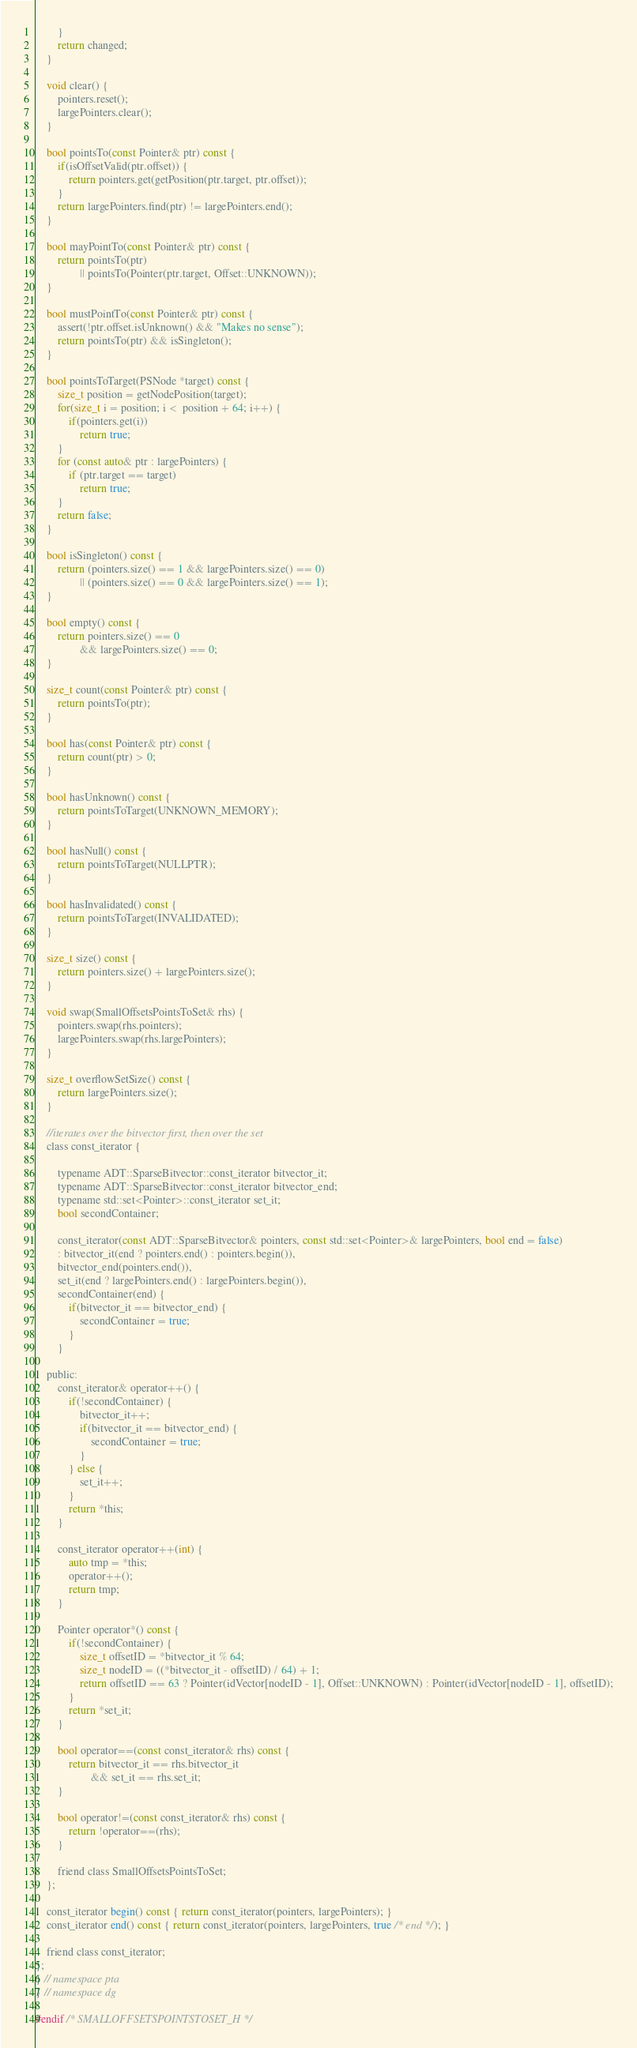Convert code to text. <code><loc_0><loc_0><loc_500><loc_500><_C_>        }
        return changed;
    }

    void clear() {
        pointers.reset();
        largePointers.clear();
    }

    bool pointsTo(const Pointer& ptr) const {
        if(isOffsetValid(ptr.offset)) {
            return pointers.get(getPosition(ptr.target, ptr.offset));
        }
        return largePointers.find(ptr) != largePointers.end();
    }

    bool mayPointTo(const Pointer& ptr) const {
        return pointsTo(ptr)
                || pointsTo(Pointer(ptr.target, Offset::UNKNOWN));
    }

    bool mustPointTo(const Pointer& ptr) const {
        assert(!ptr.offset.isUnknown() && "Makes no sense");
        return pointsTo(ptr) && isSingleton();
    }

    bool pointsToTarget(PSNode *target) const {
        size_t position = getNodePosition(target);
        for(size_t i = position; i <  position + 64; i++) {
            if(pointers.get(i))
                return true;
        }
        for (const auto& ptr : largePointers) {
            if (ptr.target == target)
                return true;
        }
        return false;
    }

    bool isSingleton() const {
        return (pointers.size() == 1 && largePointers.size() == 0)
                || (pointers.size() == 0 && largePointers.size() == 1);
    }

    bool empty() const {
        return pointers.size() == 0
                && largePointers.size() == 0;
    }

    size_t count(const Pointer& ptr) const {
        return pointsTo(ptr);
    }

    bool has(const Pointer& ptr) const {
        return count(ptr) > 0;
    }

    bool hasUnknown() const {
        return pointsToTarget(UNKNOWN_MEMORY);
    }

    bool hasNull() const {
        return pointsToTarget(NULLPTR);
    }

    bool hasInvalidated() const {
        return pointsToTarget(INVALIDATED);
    }

    size_t size() const {
        return pointers.size() + largePointers.size();
    }

    void swap(SmallOffsetsPointsToSet& rhs) {
        pointers.swap(rhs.pointers);
        largePointers.swap(rhs.largePointers);
    }

    size_t overflowSetSize() const {
        return largePointers.size();
    }

    //iterates over the bitvector first, then over the set
    class const_iterator {

        typename ADT::SparseBitvector::const_iterator bitvector_it;
        typename ADT::SparseBitvector::const_iterator bitvector_end;
        typename std::set<Pointer>::const_iterator set_it;
        bool secondContainer;

        const_iterator(const ADT::SparseBitvector& pointers, const std::set<Pointer>& largePointers, bool end = false)
        : bitvector_it(end ? pointers.end() : pointers.begin()),
        bitvector_end(pointers.end()),
        set_it(end ? largePointers.end() : largePointers.begin()),
        secondContainer(end) {
            if(bitvector_it == bitvector_end) {
                secondContainer = true;
            }
        }

    public:
        const_iterator& operator++() {
            if(!secondContainer) {
                bitvector_it++;
                if(bitvector_it == bitvector_end) {
                    secondContainer = true;
                }
            } else {
                set_it++;
            }
            return *this;
        }

        const_iterator operator++(int) {
            auto tmp = *this;
            operator++();
            return tmp;
        }

        Pointer operator*() const {
            if(!secondContainer) {
                size_t offsetID = *bitvector_it % 64;
                size_t nodeID = ((*bitvector_it - offsetID) / 64) + 1;
                return offsetID == 63 ? Pointer(idVector[nodeID - 1], Offset::UNKNOWN) : Pointer(idVector[nodeID - 1], offsetID);
            }
            return *set_it;
        }

        bool operator==(const const_iterator& rhs) const {
            return bitvector_it == rhs.bitvector_it
                    && set_it == rhs.set_it;
        }

        bool operator!=(const const_iterator& rhs) const {
            return !operator==(rhs);
        }

        friend class SmallOffsetsPointsToSet;
    };

    const_iterator begin() const { return const_iterator(pointers, largePointers); }
    const_iterator end() const { return const_iterator(pointers, largePointers, true /* end */); }

    friend class const_iterator;
};
} // namespace pta
} // namespace dg

#endif /* SMALLOFFSETSPOINTSTOSET_H */
</code> 